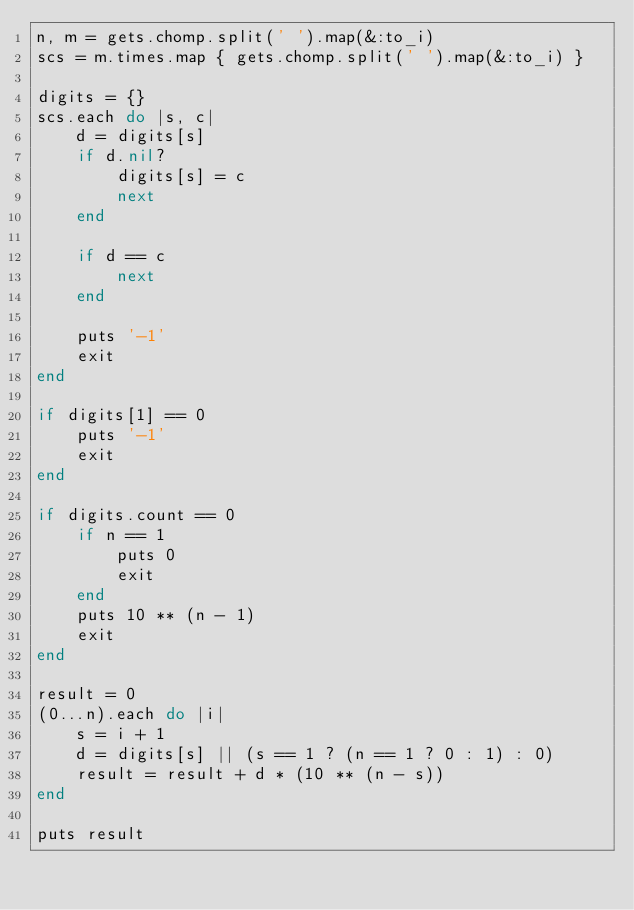<code> <loc_0><loc_0><loc_500><loc_500><_Ruby_>n, m = gets.chomp.split(' ').map(&:to_i)
scs = m.times.map { gets.chomp.split(' ').map(&:to_i) }

digits = {}
scs.each do |s, c|
    d = digits[s]
    if d.nil?
        digits[s] = c
        next
    end

    if d == c
        next
    end

    puts '-1'
    exit
end

if digits[1] == 0
    puts '-1'
    exit
end

if digits.count == 0
    if n == 1
        puts 0
        exit
    end
    puts 10 ** (n - 1)
    exit
end

result = 0
(0...n).each do |i|
    s = i + 1
    d = digits[s] || (s == 1 ? (n == 1 ? 0 : 1) : 0)
    result = result + d * (10 ** (n - s))
end

puts result
</code> 